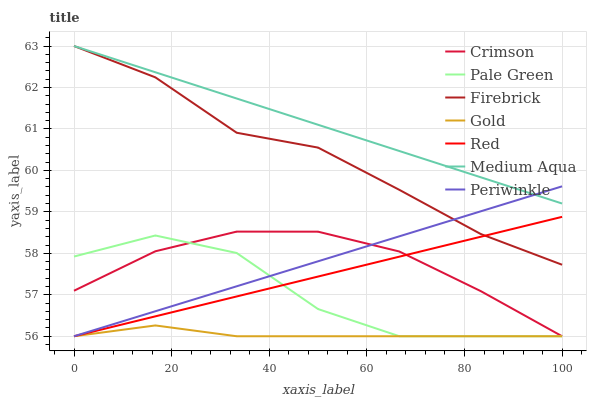Does Firebrick have the minimum area under the curve?
Answer yes or no. No. Does Firebrick have the maximum area under the curve?
Answer yes or no. No. Is Firebrick the smoothest?
Answer yes or no. No. Is Firebrick the roughest?
Answer yes or no. No. Does Firebrick have the lowest value?
Answer yes or no. No. Does Pale Green have the highest value?
Answer yes or no. No. Is Gold less than Medium Aqua?
Answer yes or no. Yes. Is Medium Aqua greater than Gold?
Answer yes or no. Yes. Does Gold intersect Medium Aqua?
Answer yes or no. No. 